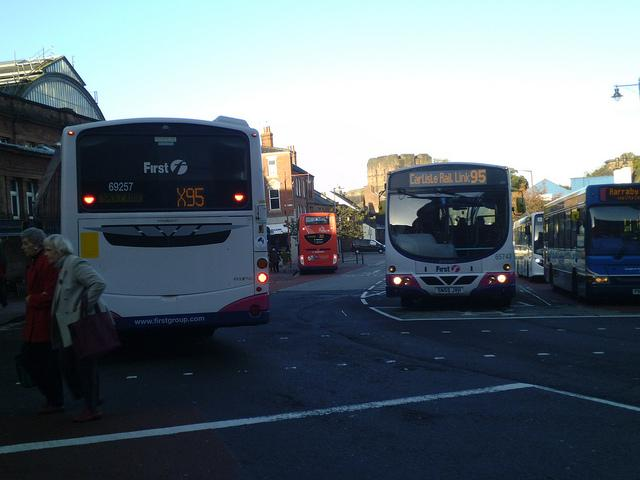In which area do these buses run?

Choices:
A) tundra
B) desert
C) urban
D) rural urban 